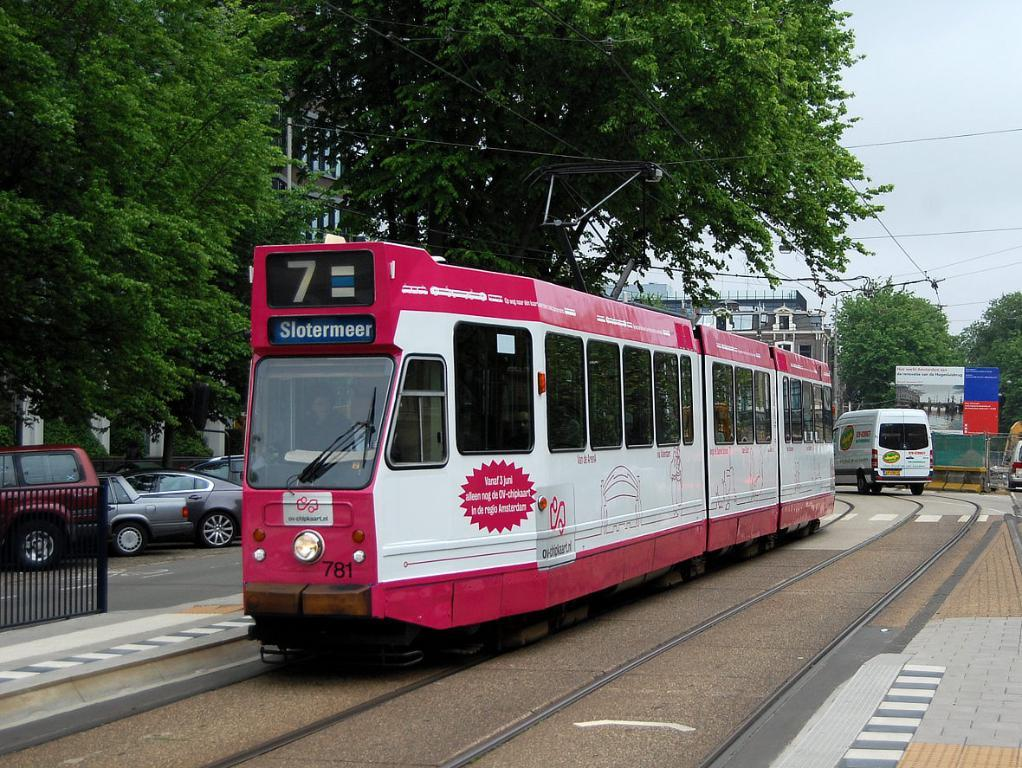Provide a one-sentence caption for the provided image. Red train going to Slotermeer going down the tracks. 